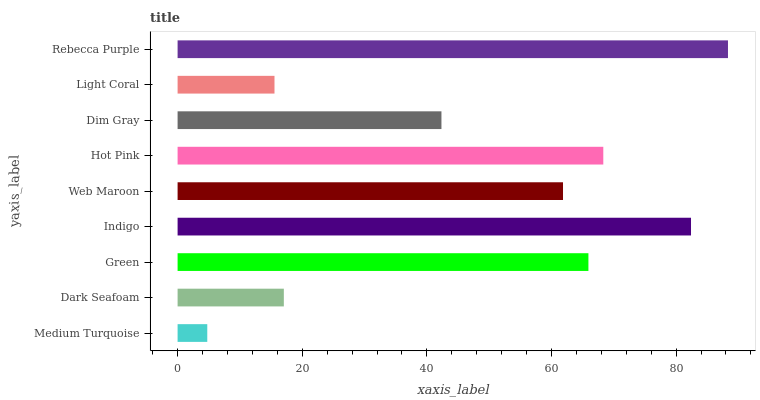Is Medium Turquoise the minimum?
Answer yes or no. Yes. Is Rebecca Purple the maximum?
Answer yes or no. Yes. Is Dark Seafoam the minimum?
Answer yes or no. No. Is Dark Seafoam the maximum?
Answer yes or no. No. Is Dark Seafoam greater than Medium Turquoise?
Answer yes or no. Yes. Is Medium Turquoise less than Dark Seafoam?
Answer yes or no. Yes. Is Medium Turquoise greater than Dark Seafoam?
Answer yes or no. No. Is Dark Seafoam less than Medium Turquoise?
Answer yes or no. No. Is Web Maroon the high median?
Answer yes or no. Yes. Is Web Maroon the low median?
Answer yes or no. Yes. Is Light Coral the high median?
Answer yes or no. No. Is Medium Turquoise the low median?
Answer yes or no. No. 